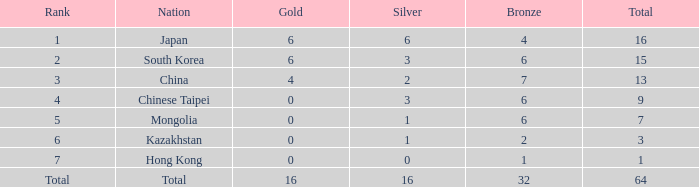Which Nation has a Gold of 0, and a Bronze smaller than 6, and a Rank of 6? Kazakhstan. 